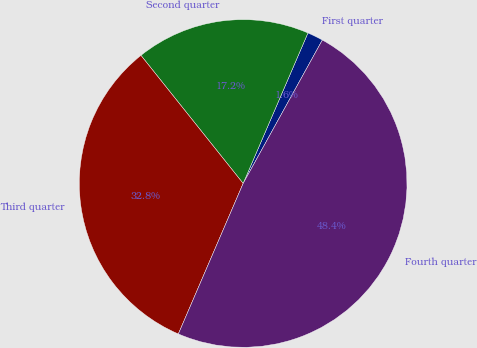Convert chart to OTSL. <chart><loc_0><loc_0><loc_500><loc_500><pie_chart><fcel>First quarter<fcel>Second quarter<fcel>Third quarter<fcel>Fourth quarter<nl><fcel>1.56%<fcel>17.19%<fcel>32.81%<fcel>48.44%<nl></chart> 